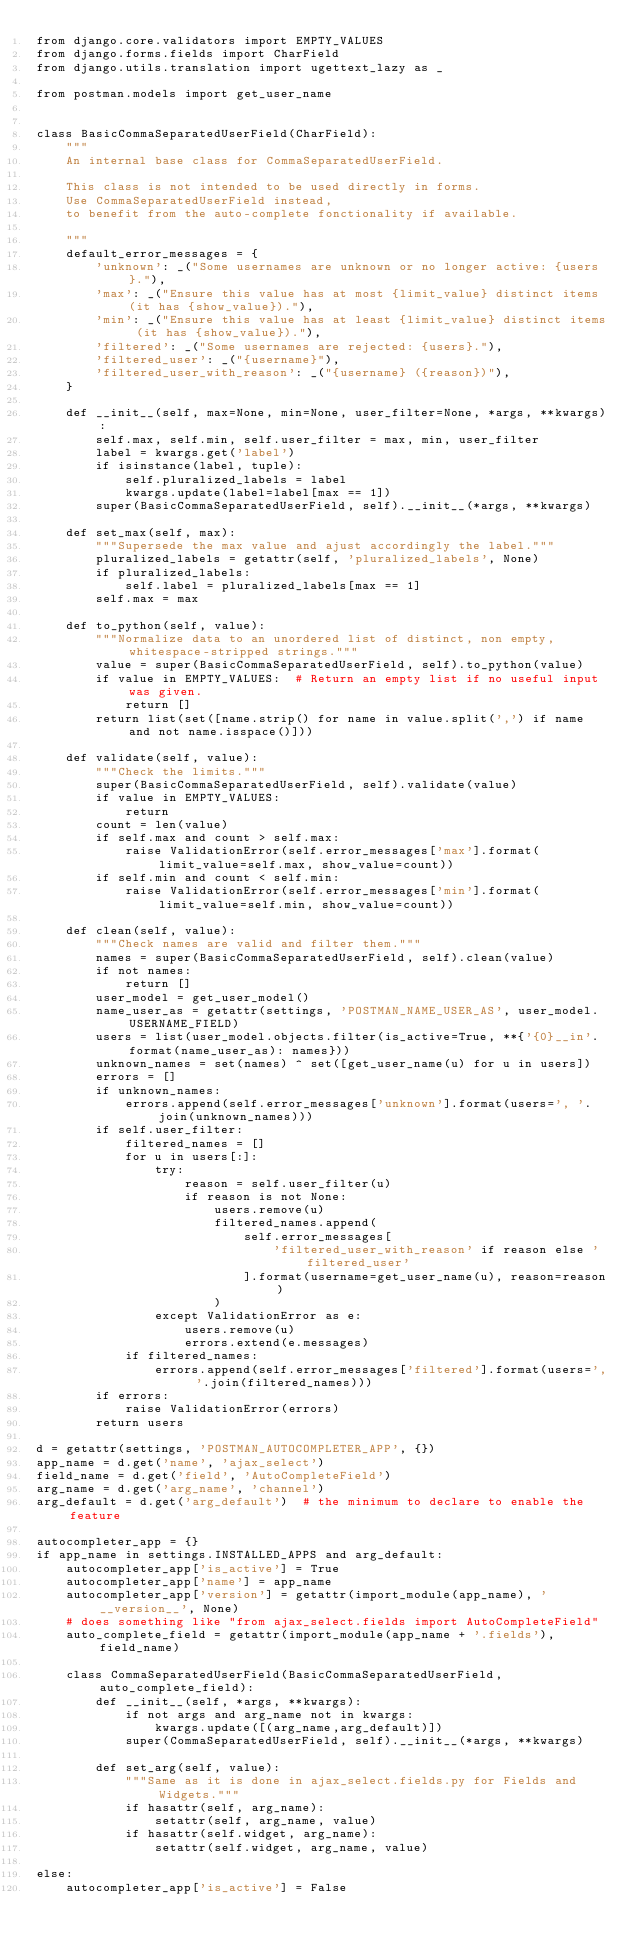Convert code to text. <code><loc_0><loc_0><loc_500><loc_500><_Python_>from django.core.validators import EMPTY_VALUES
from django.forms.fields import CharField
from django.utils.translation import ugettext_lazy as _

from postman.models import get_user_name


class BasicCommaSeparatedUserField(CharField):
    """
    An internal base class for CommaSeparatedUserField.

    This class is not intended to be used directly in forms.
    Use CommaSeparatedUserField instead,
    to benefit from the auto-complete fonctionality if available.

    """
    default_error_messages = {
        'unknown': _("Some usernames are unknown or no longer active: {users}."),
        'max': _("Ensure this value has at most {limit_value} distinct items (it has {show_value})."),
        'min': _("Ensure this value has at least {limit_value} distinct items (it has {show_value})."),
        'filtered': _("Some usernames are rejected: {users}."),
        'filtered_user': _("{username}"),
        'filtered_user_with_reason': _("{username} ({reason})"),
    }

    def __init__(self, max=None, min=None, user_filter=None, *args, **kwargs):
        self.max, self.min, self.user_filter = max, min, user_filter
        label = kwargs.get('label')
        if isinstance(label, tuple):
            self.pluralized_labels = label
            kwargs.update(label=label[max == 1])
        super(BasicCommaSeparatedUserField, self).__init__(*args, **kwargs)

    def set_max(self, max):
        """Supersede the max value and ajust accordingly the label."""
        pluralized_labels = getattr(self, 'pluralized_labels', None)
        if pluralized_labels:
            self.label = pluralized_labels[max == 1]
        self.max = max

    def to_python(self, value):
        """Normalize data to an unordered list of distinct, non empty, whitespace-stripped strings."""
        value = super(BasicCommaSeparatedUserField, self).to_python(value)
        if value in EMPTY_VALUES:  # Return an empty list if no useful input was given.
            return []
        return list(set([name.strip() for name in value.split(',') if name and not name.isspace()]))

    def validate(self, value):
        """Check the limits."""
        super(BasicCommaSeparatedUserField, self).validate(value)
        if value in EMPTY_VALUES:
            return
        count = len(value)
        if self.max and count > self.max:
            raise ValidationError(self.error_messages['max'].format(limit_value=self.max, show_value=count))
        if self.min and count < self.min:
            raise ValidationError(self.error_messages['min'].format(limit_value=self.min, show_value=count))

    def clean(self, value):
        """Check names are valid and filter them."""
        names = super(BasicCommaSeparatedUserField, self).clean(value)
        if not names:
            return []
        user_model = get_user_model()
        name_user_as = getattr(settings, 'POSTMAN_NAME_USER_AS', user_model.USERNAME_FIELD)
        users = list(user_model.objects.filter(is_active=True, **{'{0}__in'.format(name_user_as): names}))
        unknown_names = set(names) ^ set([get_user_name(u) for u in users])
        errors = []
        if unknown_names:
            errors.append(self.error_messages['unknown'].format(users=', '.join(unknown_names)))
        if self.user_filter:
            filtered_names = []
            for u in users[:]:
                try:
                    reason = self.user_filter(u)
                    if reason is not None:
                        users.remove(u)
                        filtered_names.append(
                            self.error_messages[
                                'filtered_user_with_reason' if reason else 'filtered_user'
                            ].format(username=get_user_name(u), reason=reason)
                        )
                except ValidationError as e:
                    users.remove(u)
                    errors.extend(e.messages)
            if filtered_names:
                errors.append(self.error_messages['filtered'].format(users=', '.join(filtered_names)))
        if errors:
            raise ValidationError(errors)
        return users

d = getattr(settings, 'POSTMAN_AUTOCOMPLETER_APP', {})
app_name = d.get('name', 'ajax_select')
field_name = d.get('field', 'AutoCompleteField')
arg_name = d.get('arg_name', 'channel')
arg_default = d.get('arg_default')  # the minimum to declare to enable the feature

autocompleter_app = {}
if app_name in settings.INSTALLED_APPS and arg_default:
    autocompleter_app['is_active'] = True
    autocompleter_app['name'] = app_name
    autocompleter_app['version'] = getattr(import_module(app_name), '__version__', None)
    # does something like "from ajax_select.fields import AutoCompleteField"
    auto_complete_field = getattr(import_module(app_name + '.fields'), field_name)

    class CommaSeparatedUserField(BasicCommaSeparatedUserField, auto_complete_field):
        def __init__(self, *args, **kwargs):
            if not args and arg_name not in kwargs:
                kwargs.update([(arg_name,arg_default)])
            super(CommaSeparatedUserField, self).__init__(*args, **kwargs)

        def set_arg(self, value):
            """Same as it is done in ajax_select.fields.py for Fields and Widgets."""
            if hasattr(self, arg_name):
                setattr(self, arg_name, value)
            if hasattr(self.widget, arg_name):
                setattr(self.widget, arg_name, value)

else:
    autocompleter_app['is_active'] = False</code> 